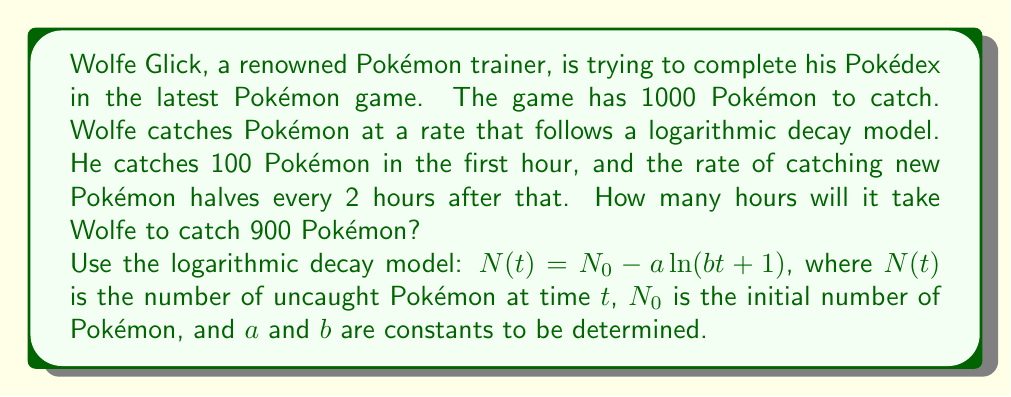Can you answer this question? Let's approach this step-by-step:

1) First, we need to determine the constants $a$ and $b$ in our model:
   $N(t) = 1000 - a \ln(bt + 1)$

2) We know that after 1 hour (t = 1), Wolfe has caught 100 Pokémon, so 900 remain:
   $900 = 1000 - a \ln(b + 1)$

3) We also know that the rate halves every 2 hours. The rate is the derivative of our function:
   $\frac{dN}{dt} = -\frac{ab}{bt + 1}$

4) At t = 0, the rate is 100 Pokémon per hour:
   $100 = ab$

5) At t = 2, the rate should be 50 Pokémon per hour:
   $50 = \frac{ab}{2b + 1}$

6) From steps 4 and 5:
   $50 = \frac{100}{2b + 1}$
   $2b + 1 = 2$
   $b = 0.5$

7) Then from step 4:
   $a = 100/0.5 = 200$

8) Now our model is:
   $N(t) = 1000 - 200 \ln(0.5t + 1)$

9) We want to find t when N(t) = 100 (as 900 have been caught):
   $100 = 1000 - 200 \ln(0.5t + 1)$
   $4.5 = \ln(0.5t + 1)$
   $e^{4.5} = 0.5t + 1$
   $89.0166 = 0.5t + 1$
   $88.0166 = 0.5t$
   $t = 176.0332$

Therefore, it will take approximately 176.03 hours for Wolfe to catch 900 Pokémon.
Answer: Approximately 176.03 hours 